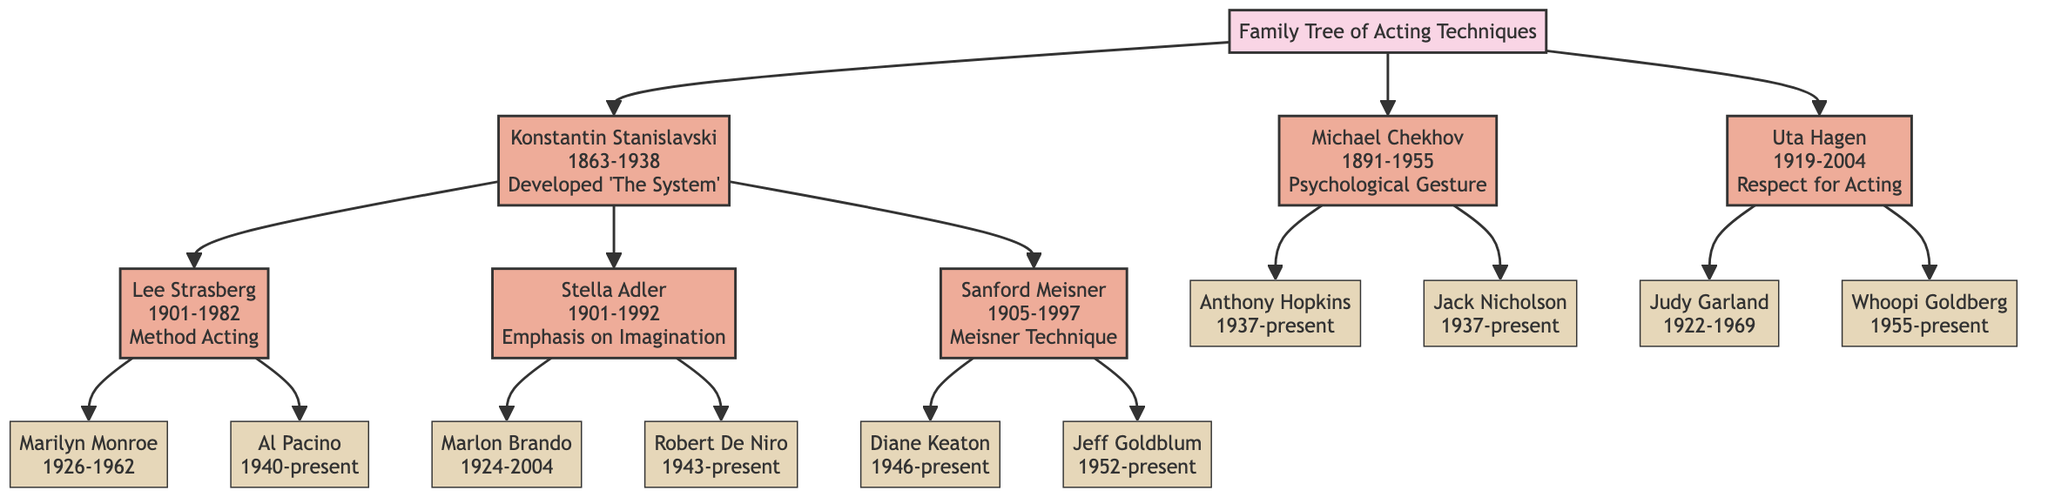What is the influence of Konstantin Stanislavski? The diagram lists the influence of Konstantin Stanislavski as "Developed 'The System'." This information is found directly under Stanislavski's node in the diagram.
Answer: Developed 'The System' How many main branches are there in the family tree? The diagram starts with one main node and has three main branches stemming from it: Stanislavski, Michael Chekhov, and Uta Hagen. Counting these gives a total of three main branches.
Answer: 3 Who is a child of Lee Strasberg? The diagram outlines that Lee Strasberg's children include Marilyn Monroe and Al Pacino. Looking at the branch connected to Strasberg leads to these two names.
Answer: Marilyn Monroe and Al Pacino What acting technique did Sanford Meisner develop? The diagram shows that Sanford Meisner developed the "Meisner Technique." This is indicated right below his name in the diagram, representing his contribution to acting techniques.
Answer: Meisner Technique Which actor influenced Judy Garland? The diagram indicates that Judy Garland is a child of Uta Hagen. Therefore, Uta Hagen is the actress who influenced her, evidenced by the direct line connecting their nodes.
Answer: Uta Hagen Who are the notable works of Robert De Niro? Under Robert De Niro's node, the notable works listed are "Raging Bull" and "Taxi Driver." This information is directly provided as part of his description in the family tree.
Answer: Raging Bull, Taxi Driver How is Michael Chekhov related to Stanislavski? The diagram shows that Michael Chekhov is a separate branch from Stanislavski but shares a common ancestor with other acting techniques emerging from Stanislavski's influence. Thus, Chekhov is indirectly connected to Stanislavski through the shared lineage of acting methodologies.
Answer: Indirectly related Which two actors were influenced by Sanford Meisner? Looking at the diagram, it is clear that Diane Keaton and Jeff Goldblum are the two actors that fall under Sanford Meisner's influence. They appear directly below his name as his children in the family tree.
Answer: Diane Keaton and Jeff Goldblum What is the notable work of Anthony Hopkins? The diagram specifies that Anthony Hopkins' notable works include "The Silence of the Lambs" and "The Remains of the Day," which are listed directly beneath his name in the tree structure.
Answer: The Silence of the Lambs, The Remains of the Day 